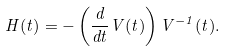<formula> <loc_0><loc_0><loc_500><loc_500>H ( t ) = - \left ( \frac { d } { d t } V ( t ) \right ) V ^ { - 1 } ( t ) .</formula> 